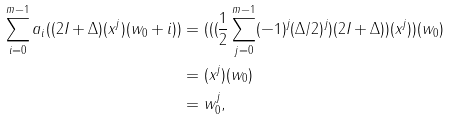Convert formula to latex. <formula><loc_0><loc_0><loc_500><loc_500>\sum _ { i = 0 } ^ { m - 1 } a _ { i } ( ( 2 I + \Delta ) ( x ^ { j } ) ( w _ { 0 } + i ) ) & = ( ( ( \frac { 1 } { 2 } \sum _ { j = 0 } ^ { m - 1 } ( - 1 ) ^ { j } ( \Delta / 2 ) ^ { j } ) ( 2 I + \Delta ) ) ( x ^ { j } ) ) ( w _ { 0 } ) \\ & = ( x ^ { j } ) ( w _ { 0 } ) \\ & = w _ { 0 } ^ { j } ,</formula> 